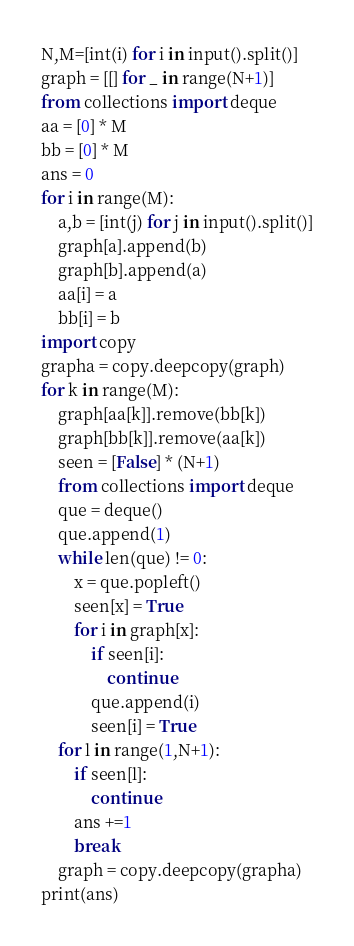Convert code to text. <code><loc_0><loc_0><loc_500><loc_500><_Python_>N,M=[int(i) for i in input().split()]
graph = [[] for _ in range(N+1)]
from collections import deque
aa = [0] * M
bb = [0] * M
ans = 0
for i in range(M):
    a,b = [int(j) for j in input().split()]
    graph[a].append(b)
    graph[b].append(a)
    aa[i] = a
    bb[i] = b
import copy
grapha = copy.deepcopy(graph)
for k in range(M):
    graph[aa[k]].remove(bb[k])
    graph[bb[k]].remove(aa[k])
    seen = [False] * (N+1)
    from collections import deque
    que = deque()
    que.append(1)
    while len(que) != 0:
        x = que.popleft()
        seen[x] = True
        for i in graph[x]:
            if seen[i]:
                continue
            que.append(i)
            seen[i] = True
    for l in range(1,N+1):
        if seen[l]:
            continue
        ans +=1
        break
    graph = copy.deepcopy(grapha)
print(ans)</code> 